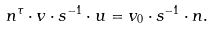Convert formula to latex. <formula><loc_0><loc_0><loc_500><loc_500>n ^ { \tau } \cdot v \cdot s ^ { - 1 } \cdot u = v _ { 0 } \cdot s ^ { - 1 } \cdot n .</formula> 